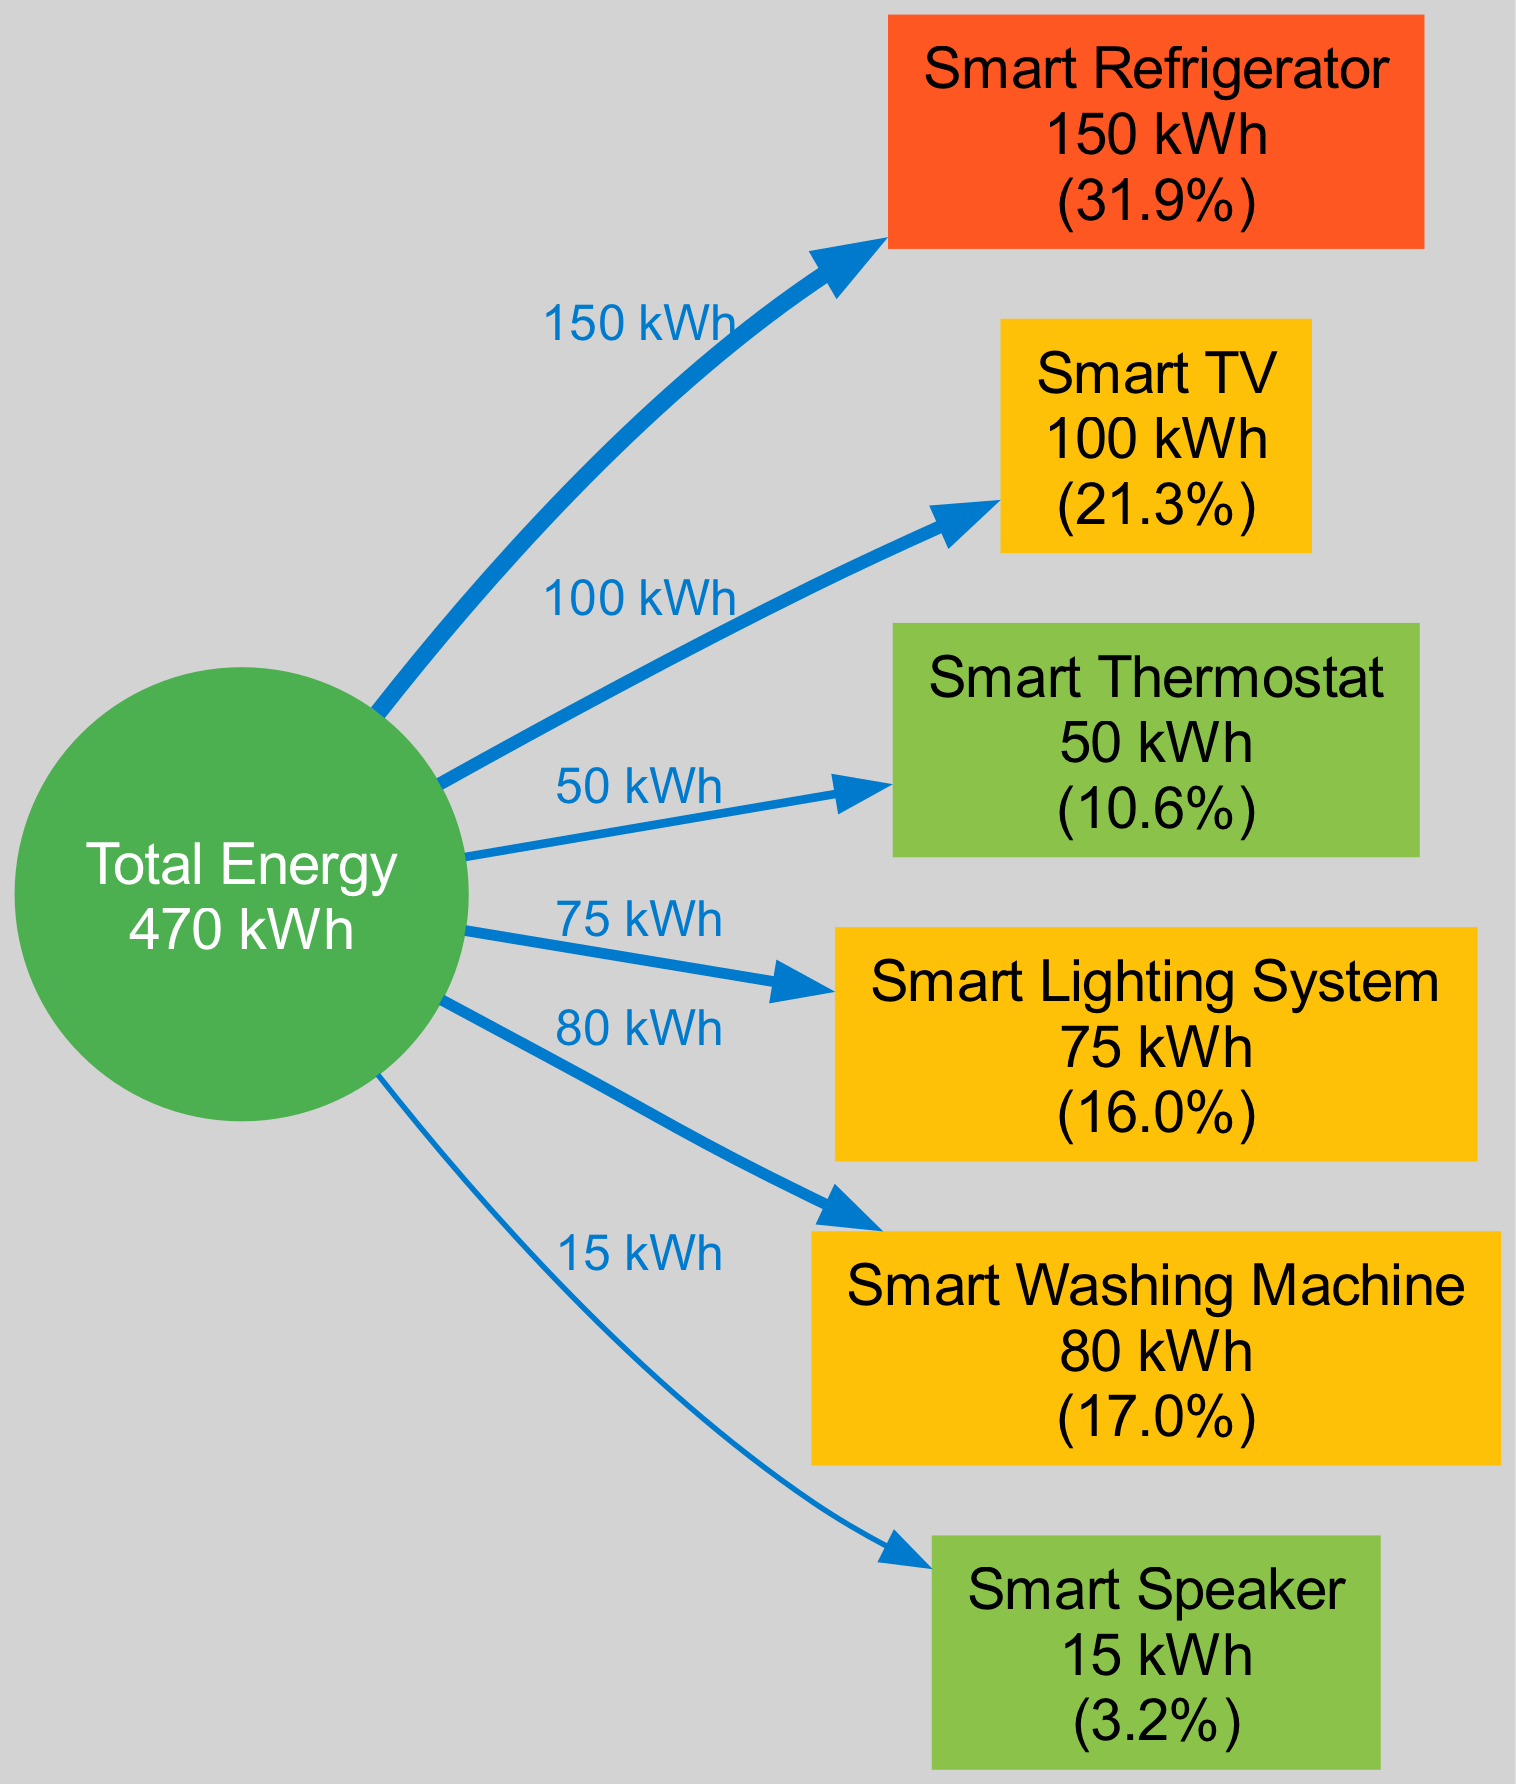What is the total energy consumed in the smart home environment? The "Total" node in the diagram displays the total energy consumed. In this case, it shows "Total Energy 470 kWh", thus indicating that the total energy consumption in the smart home environment is 470 kWh.
Answer: 470 kWh Which device consumes the most energy? By examining the sizes of the flows leading to each device from the "Total" node, the "Smart Refrigerator" has the largest flow, representing its energy consumption of 150 kWh, which is the highest among all devices.
Answer: Smart Refrigerator What percentage of total energy does the Smart Thermostat consume? The diagram shows the Smart Thermostat consuming 50 kWh. To find the percentage, the calculation (50/470)*100 is performed, resulting in approximately 10.6%. This percentage is displayed next to the Smart Thermostat node.
Answer: 10.6% How many devices are represented in the diagram? The diagram contains a node for each of the six listed devices. By simply counting these nodes representing the "Smart Refrigerator," "Smart TV," "Smart Thermostat," "Smart Lighting System," "Smart Washing Machine," and "Smart Speaker," we find that there are six devices total.
Answer: 6 Which device has the lowest energy consumption? The Smart Speaker shows the smallest flow, indicating its lowest energy consumption of 15 kWh, which is less than all other devices represented in the diagram.
Answer: Smart Speaker How much energy does the Smart Lighting System consume compared to the total energy? The Smart Lighting System consumes 75 kWh, which details its contribution to the total energy consumption of 470 kWh. The answer is obtained from the value shown on the Smart Lighting System node and the total at the "Total" node, thus revealing the system's share of total energy.
Answer: 75 kWh Which color represents the Smart Washing Machine in the diagram? The Smart Washing Machine node is colored to indicate its level of energy consumption. Since it consumes 80 kWh, which is above 50 but below 100, it falls under the color classification of '#FFC107', which is a yellowish hue.
Answer: Yellow What is the total energy consumed by devices consuming more than 50 kWh? By totaling the energy of devices above that threshold, which includes the Smart Refrigerator (150 kWh), Smart TV (100 kWh), Smart Lighting System (75 kWh), and Smart Washing Machine (80 kWh), the total is calculated as 150 + 100 + 75 + 80 = 405 kWh.
Answer: 405 kWh 